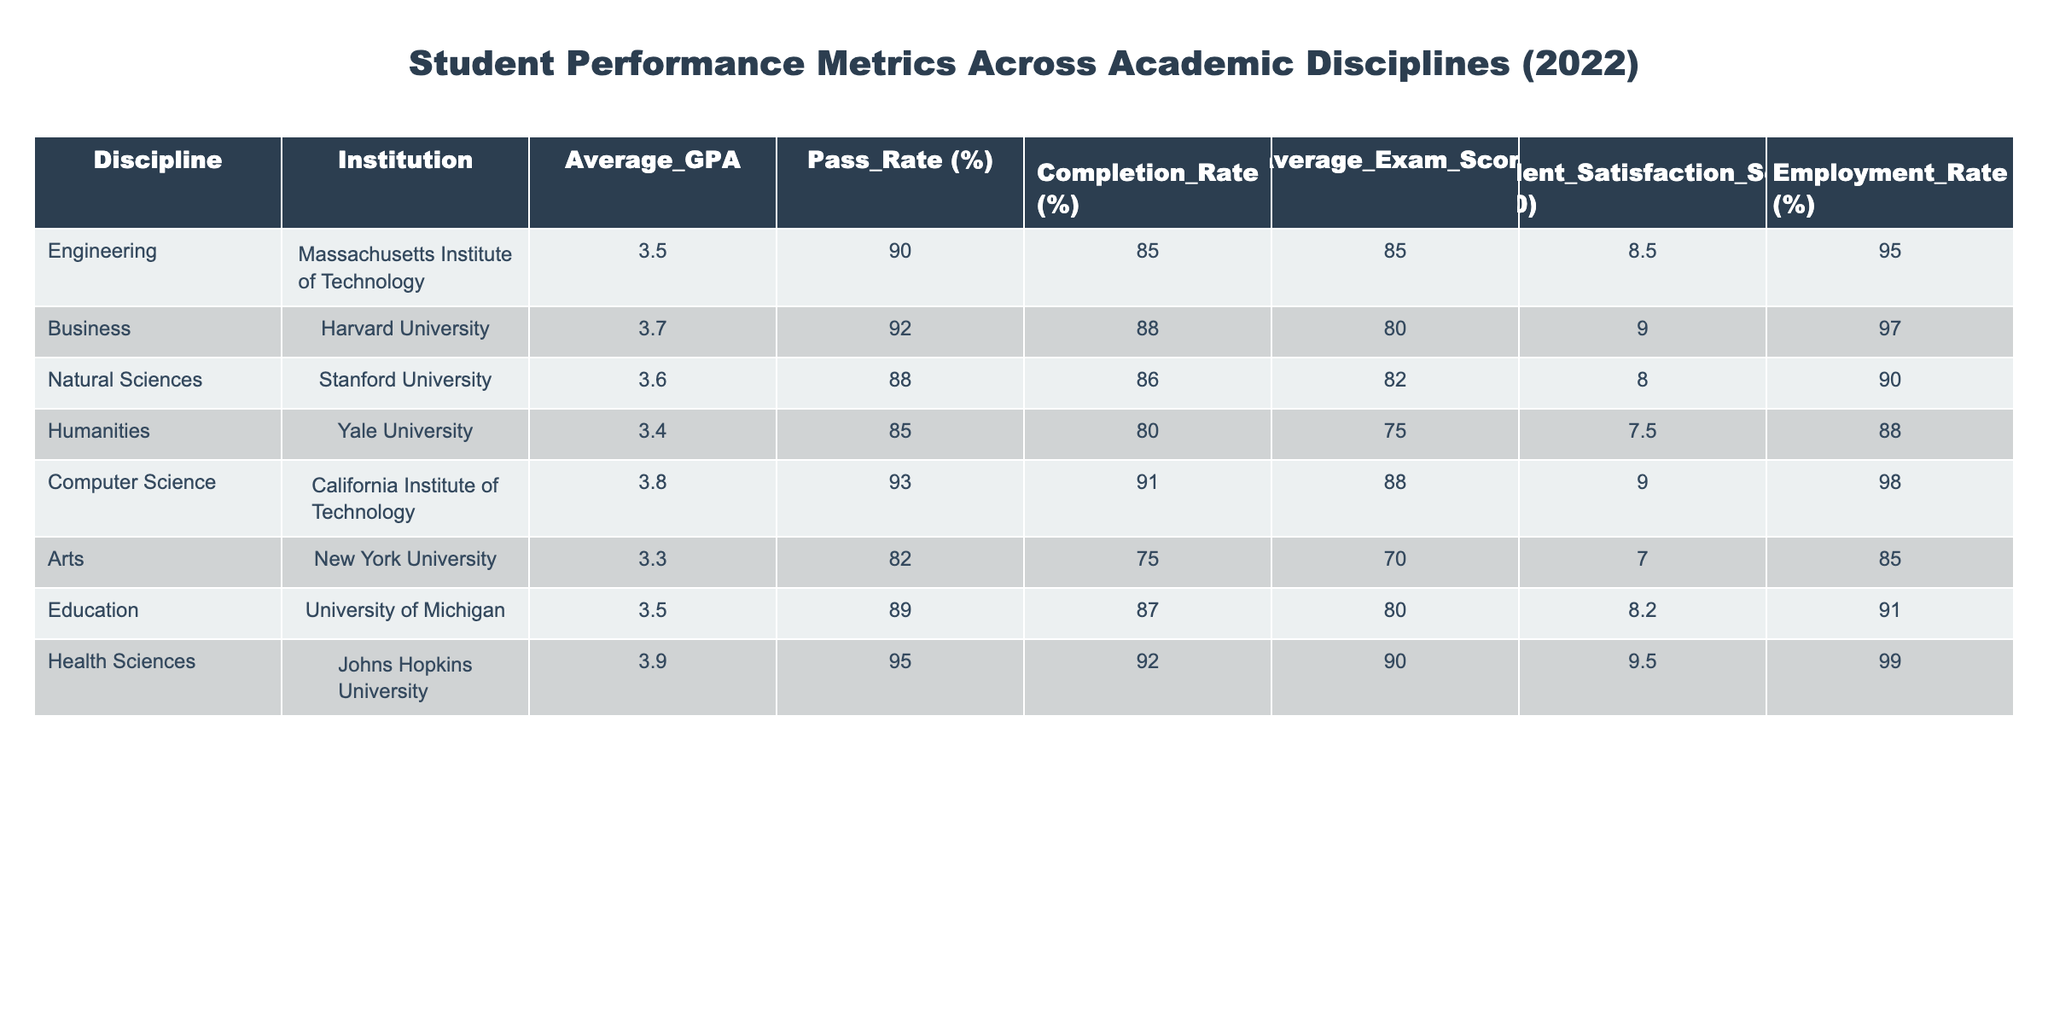What is the highest Average_GPA among the disciplines? By reviewing the data in the table, the discipline with the highest Average_GPA is Computer Science, which has an Average_GPA of 3.8.
Answer: 3.8 Which discipline has the lowest Pass Rate? The Pass Rate can be compared by examining the values across all disciplines. The lowest Pass Rate is for the Arts discipline, which has a Pass Rate of 82%.
Answer: 82% What is the average Employment Rate of all disciplines? To determine the average Employment Rate, we sum the Employment Rates and divide by the number of disciplines: (95 + 97 + 90 + 88 + 98 + 85 + 91 + 99) = 93.875, and when rounded, the average Employment Rate is 93.88%.
Answer: 93.88% Is the Completion Rate for Engineering higher than for Humanities? By checking the Completion Rates in the table, Engineering has a Completion Rate of 85%, whereas Humanities has a Completion Rate of 80%. Since 85% is greater than 80%, the statement is true.
Answer: Yes Which discipline has the highest Student Satisfaction Score, and what is that score? The Student Satisfaction Scores are listed in the table. The highest score is 9.5 for Health Sciences.
Answer: Health Sciences, 9.5 What is the difference in Average Exam Score between Engineering and Health Sciences? By subtracting the Average Exam Score of Engineering (85) from that of Health Sciences (90), we find the difference is 90 - 85 = 5.
Answer: 5 Which discipline has a lower Average GPA: Humanities or Arts? Comparing the Average GPA of Humanities (3.4) and Arts (3.3), we can see that Arts has a lower GPA.
Answer: Arts What percentage of students in Natural Sciences are employed? The Employment Rate for Natural Sciences is explicitly shown in the table as 90%.
Answer: 90% How does the Average Exam Score of Computer Science compare to the Average Exam Score of Business? The Average Exam Score for Computer Science is 88, while for Business, it is 80. Comparing these scores shows that Computer Science has a higher Average Exam Score.
Answer: Higher What is the total Student Satisfaction Score for all institutions listed? Adding the Student Satisfaction Scores gives (8.5 + 9 + 8 + 7.5 + 9 + 7 + 8.2 + 9.5) = 67.7.
Answer: 67.7 